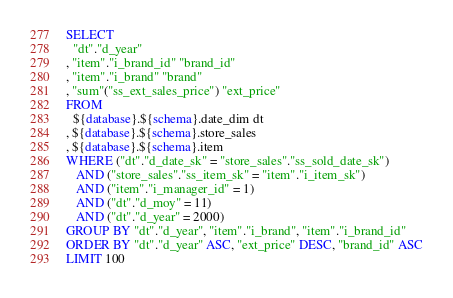<code> <loc_0><loc_0><loc_500><loc_500><_SQL_>SELECT
  "dt"."d_year"
, "item"."i_brand_id" "brand_id"
, "item"."i_brand" "brand"
, "sum"("ss_ext_sales_price") "ext_price"
FROM
  ${database}.${schema}.date_dim dt
, ${database}.${schema}.store_sales
, ${database}.${schema}.item
WHERE ("dt"."d_date_sk" = "store_sales"."ss_sold_date_sk")
   AND ("store_sales"."ss_item_sk" = "item"."i_item_sk")
   AND ("item"."i_manager_id" = 1)
   AND ("dt"."d_moy" = 11)
   AND ("dt"."d_year" = 2000)
GROUP BY "dt"."d_year", "item"."i_brand", "item"."i_brand_id"
ORDER BY "dt"."d_year" ASC, "ext_price" DESC, "brand_id" ASC
LIMIT 100
</code> 